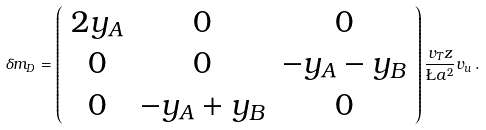Convert formula to latex. <formula><loc_0><loc_0><loc_500><loc_500>\delta m _ { D } = \left ( \begin{array} { c c c } 2 y _ { A } & 0 & 0 \\ 0 & 0 & - y _ { A } - y _ { B } \\ 0 & - y _ { A } + y _ { B } & 0 \end{array} \right ) \frac { v _ { T } z } { \L a ^ { 2 } } v _ { u } \, .</formula> 